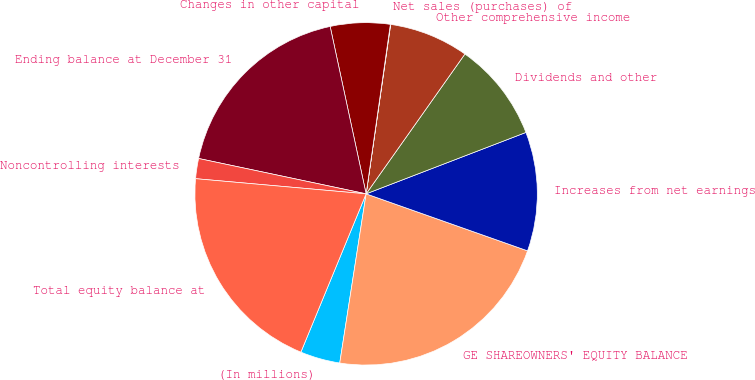Convert chart to OTSL. <chart><loc_0><loc_0><loc_500><loc_500><pie_chart><fcel>(In millions)<fcel>GE SHAREOWNERS' EQUITY BALANCE<fcel>Increases from net earnings<fcel>Dividends and other<fcel>Other comprehensive income<fcel>Net sales (purchases) of<fcel>Changes in other capital<fcel>Ending balance at December 31<fcel>Noncontrolling interests<fcel>Total equity balance at<nl><fcel>3.76%<fcel>22.06%<fcel>11.24%<fcel>9.37%<fcel>7.5%<fcel>0.03%<fcel>5.63%<fcel>18.32%<fcel>1.9%<fcel>20.19%<nl></chart> 